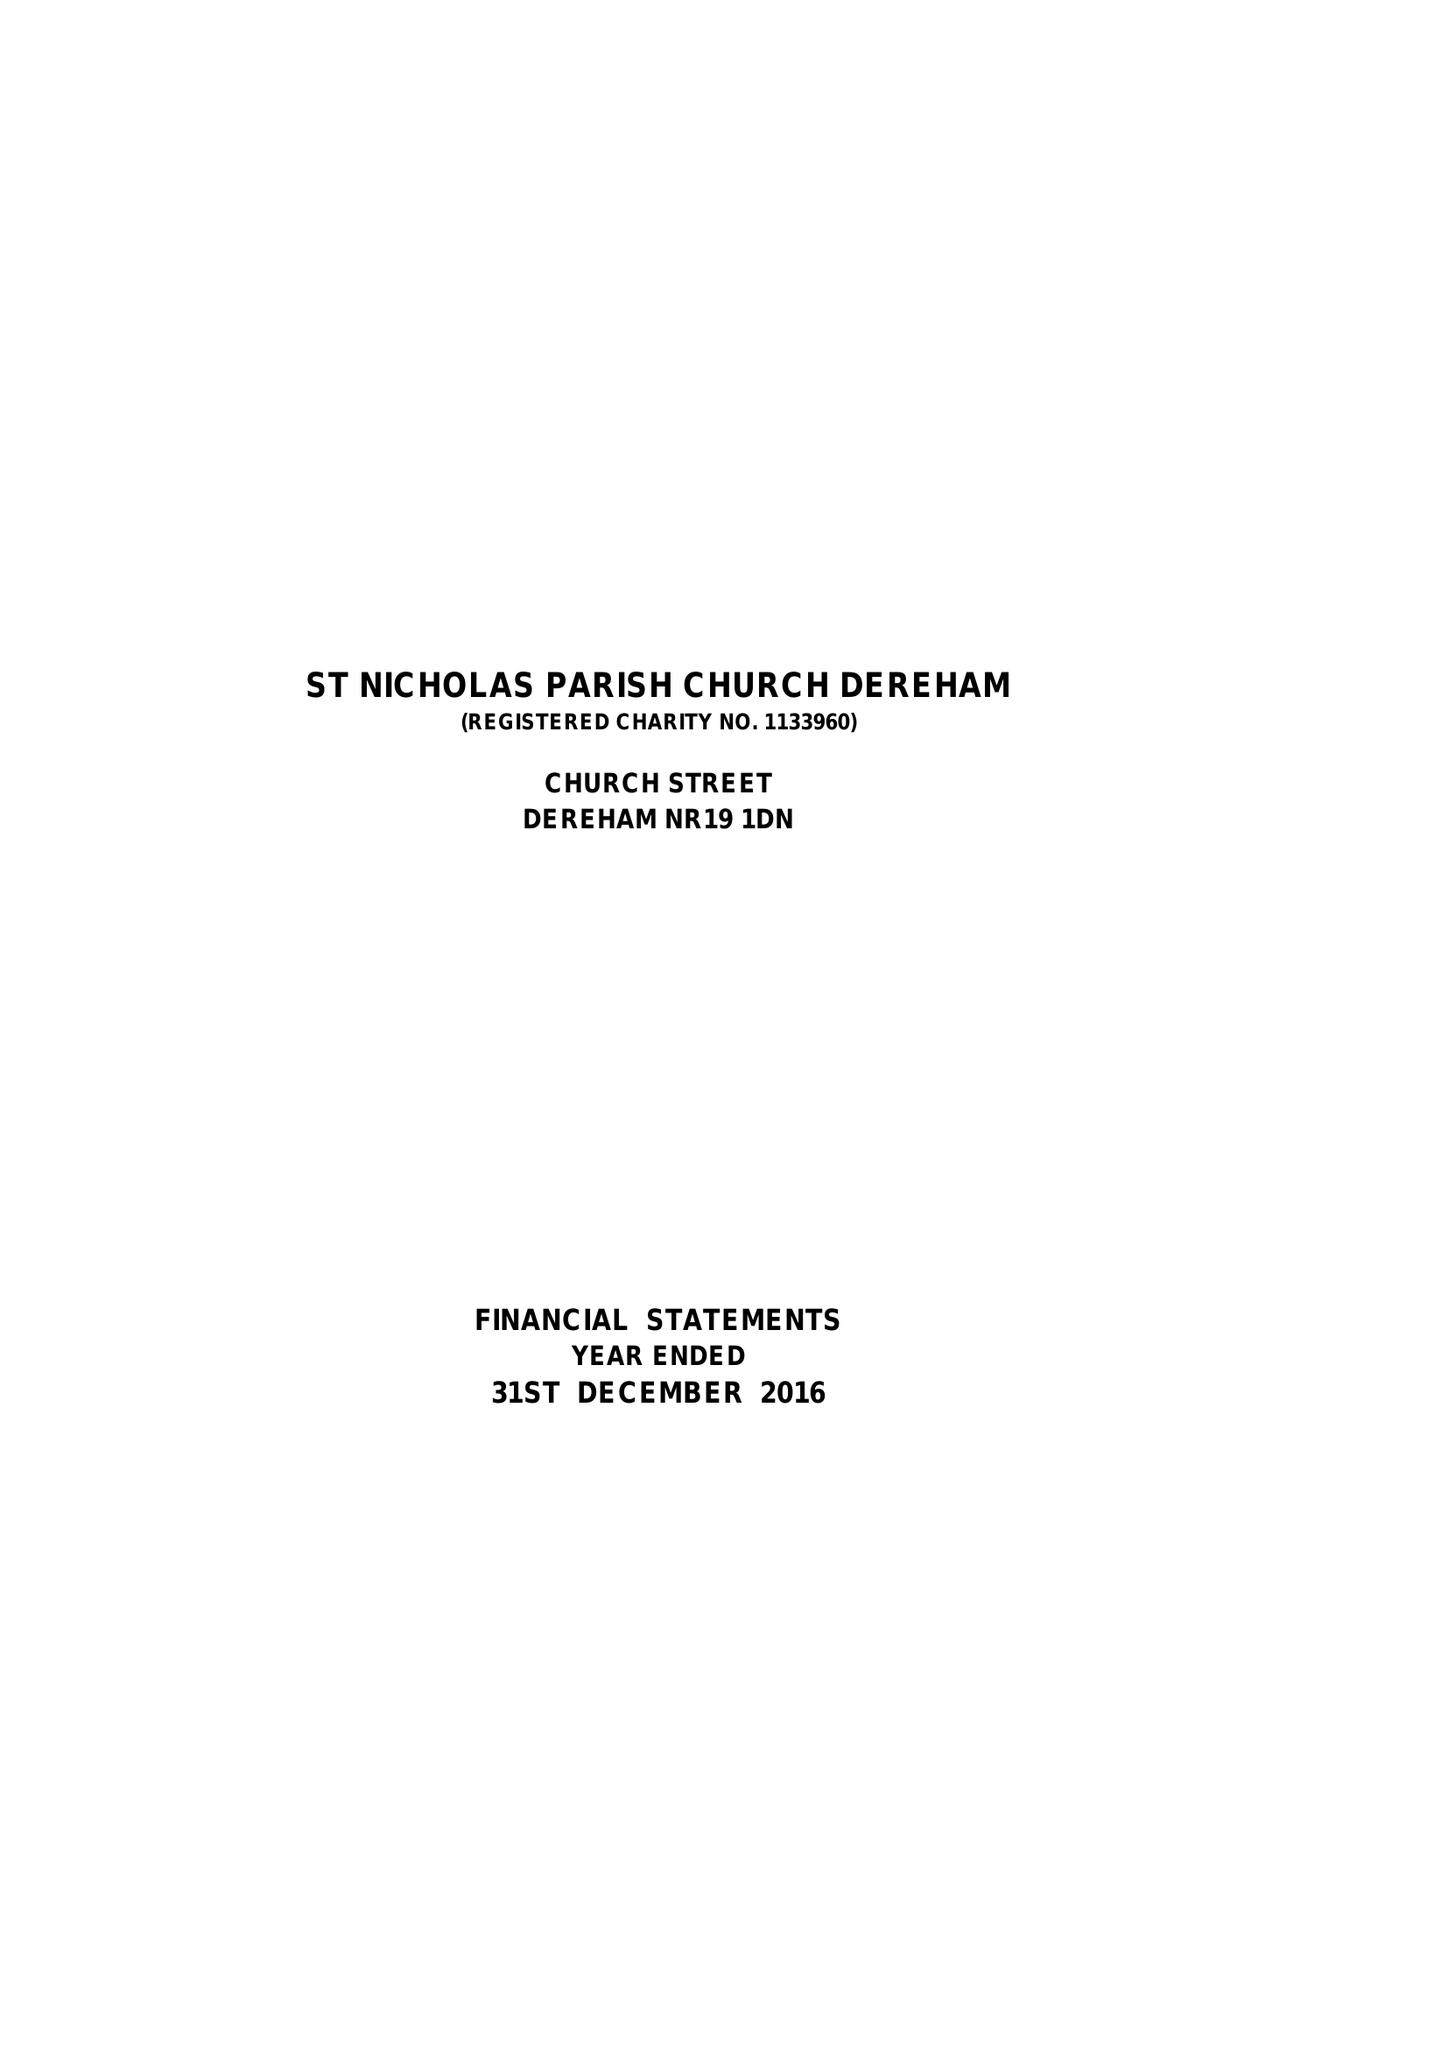What is the value for the charity_number?
Answer the question using a single word or phrase. 1133960 